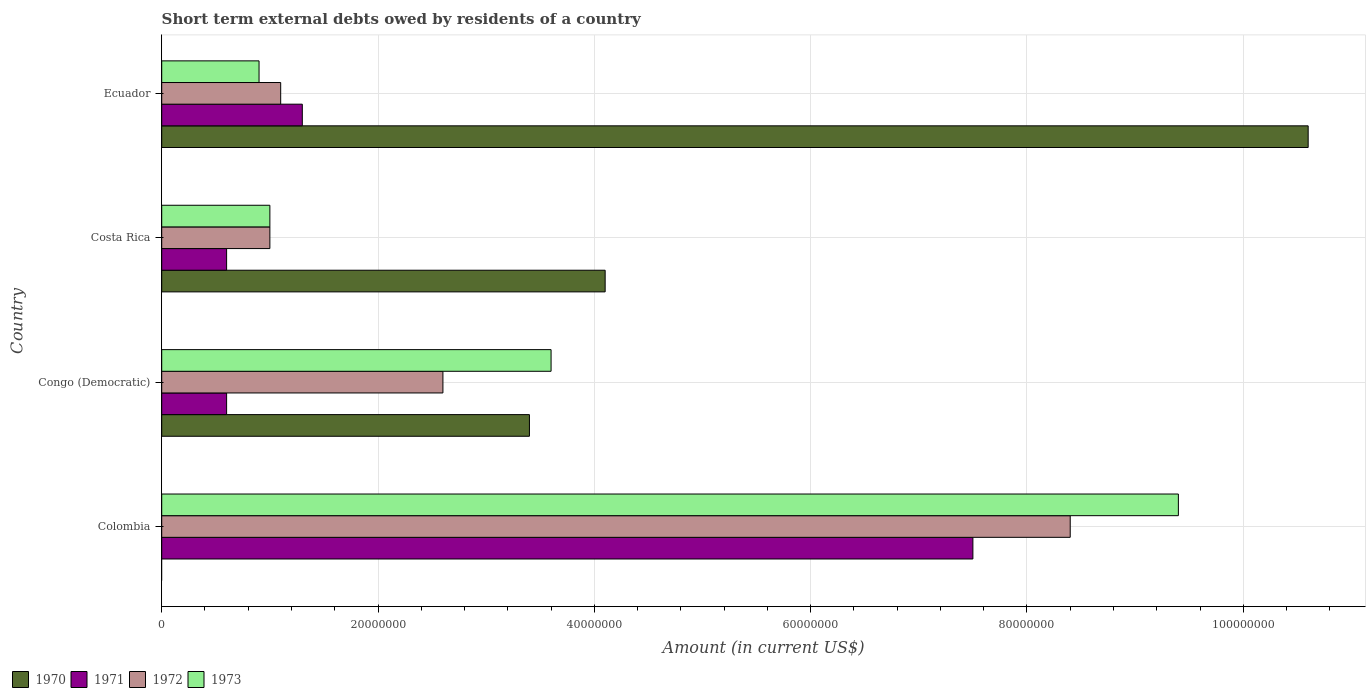How many different coloured bars are there?
Make the answer very short. 4. How many groups of bars are there?
Your answer should be very brief. 4. Are the number of bars per tick equal to the number of legend labels?
Your response must be concise. No. How many bars are there on the 2nd tick from the bottom?
Your response must be concise. 4. In how many cases, is the number of bars for a given country not equal to the number of legend labels?
Your response must be concise. 1. What is the amount of short-term external debts owed by residents in 1971 in Costa Rica?
Your answer should be very brief. 6.00e+06. Across all countries, what is the maximum amount of short-term external debts owed by residents in 1971?
Your response must be concise. 7.50e+07. Across all countries, what is the minimum amount of short-term external debts owed by residents in 1971?
Make the answer very short. 6.00e+06. In which country was the amount of short-term external debts owed by residents in 1970 maximum?
Your answer should be compact. Ecuador. What is the difference between the amount of short-term external debts owed by residents in 1971 in Colombia and that in Costa Rica?
Keep it short and to the point. 6.90e+07. What is the difference between the amount of short-term external debts owed by residents in 1972 in Costa Rica and the amount of short-term external debts owed by residents in 1970 in Ecuador?
Ensure brevity in your answer.  -9.60e+07. What is the average amount of short-term external debts owed by residents in 1971 per country?
Provide a short and direct response. 2.50e+07. What is the difference between the amount of short-term external debts owed by residents in 1972 and amount of short-term external debts owed by residents in 1971 in Costa Rica?
Give a very brief answer. 4.00e+06. In how many countries, is the amount of short-term external debts owed by residents in 1971 greater than 64000000 US$?
Offer a terse response. 1. Is the difference between the amount of short-term external debts owed by residents in 1972 in Colombia and Congo (Democratic) greater than the difference between the amount of short-term external debts owed by residents in 1971 in Colombia and Congo (Democratic)?
Provide a succinct answer. No. What is the difference between the highest and the second highest amount of short-term external debts owed by residents in 1972?
Provide a short and direct response. 5.80e+07. What is the difference between the highest and the lowest amount of short-term external debts owed by residents in 1973?
Your response must be concise. 8.50e+07. In how many countries, is the amount of short-term external debts owed by residents in 1973 greater than the average amount of short-term external debts owed by residents in 1973 taken over all countries?
Your answer should be very brief. 1. Is it the case that in every country, the sum of the amount of short-term external debts owed by residents in 1970 and amount of short-term external debts owed by residents in 1973 is greater than the sum of amount of short-term external debts owed by residents in 1972 and amount of short-term external debts owed by residents in 1971?
Make the answer very short. No. Are all the bars in the graph horizontal?
Keep it short and to the point. Yes. How many countries are there in the graph?
Make the answer very short. 4. Does the graph contain grids?
Keep it short and to the point. Yes. What is the title of the graph?
Your response must be concise. Short term external debts owed by residents of a country. What is the label or title of the X-axis?
Your answer should be compact. Amount (in current US$). What is the Amount (in current US$) in 1971 in Colombia?
Offer a terse response. 7.50e+07. What is the Amount (in current US$) in 1972 in Colombia?
Your answer should be very brief. 8.40e+07. What is the Amount (in current US$) of 1973 in Colombia?
Make the answer very short. 9.40e+07. What is the Amount (in current US$) of 1970 in Congo (Democratic)?
Offer a terse response. 3.40e+07. What is the Amount (in current US$) in 1972 in Congo (Democratic)?
Give a very brief answer. 2.60e+07. What is the Amount (in current US$) of 1973 in Congo (Democratic)?
Provide a succinct answer. 3.60e+07. What is the Amount (in current US$) of 1970 in Costa Rica?
Ensure brevity in your answer.  4.10e+07. What is the Amount (in current US$) in 1971 in Costa Rica?
Give a very brief answer. 6.00e+06. What is the Amount (in current US$) of 1972 in Costa Rica?
Give a very brief answer. 1.00e+07. What is the Amount (in current US$) of 1970 in Ecuador?
Provide a short and direct response. 1.06e+08. What is the Amount (in current US$) in 1971 in Ecuador?
Provide a succinct answer. 1.30e+07. What is the Amount (in current US$) of 1972 in Ecuador?
Offer a terse response. 1.10e+07. What is the Amount (in current US$) in 1973 in Ecuador?
Your answer should be compact. 9.00e+06. Across all countries, what is the maximum Amount (in current US$) of 1970?
Your answer should be compact. 1.06e+08. Across all countries, what is the maximum Amount (in current US$) in 1971?
Give a very brief answer. 7.50e+07. Across all countries, what is the maximum Amount (in current US$) in 1972?
Offer a terse response. 8.40e+07. Across all countries, what is the maximum Amount (in current US$) of 1973?
Offer a terse response. 9.40e+07. Across all countries, what is the minimum Amount (in current US$) in 1972?
Offer a terse response. 1.00e+07. Across all countries, what is the minimum Amount (in current US$) in 1973?
Provide a short and direct response. 9.00e+06. What is the total Amount (in current US$) in 1970 in the graph?
Offer a very short reply. 1.81e+08. What is the total Amount (in current US$) in 1971 in the graph?
Provide a short and direct response. 1.00e+08. What is the total Amount (in current US$) of 1972 in the graph?
Keep it short and to the point. 1.31e+08. What is the total Amount (in current US$) in 1973 in the graph?
Give a very brief answer. 1.49e+08. What is the difference between the Amount (in current US$) in 1971 in Colombia and that in Congo (Democratic)?
Keep it short and to the point. 6.90e+07. What is the difference between the Amount (in current US$) in 1972 in Colombia and that in Congo (Democratic)?
Keep it short and to the point. 5.80e+07. What is the difference between the Amount (in current US$) of 1973 in Colombia and that in Congo (Democratic)?
Give a very brief answer. 5.80e+07. What is the difference between the Amount (in current US$) in 1971 in Colombia and that in Costa Rica?
Provide a short and direct response. 6.90e+07. What is the difference between the Amount (in current US$) in 1972 in Colombia and that in Costa Rica?
Offer a terse response. 7.40e+07. What is the difference between the Amount (in current US$) in 1973 in Colombia and that in Costa Rica?
Give a very brief answer. 8.40e+07. What is the difference between the Amount (in current US$) of 1971 in Colombia and that in Ecuador?
Give a very brief answer. 6.20e+07. What is the difference between the Amount (in current US$) of 1972 in Colombia and that in Ecuador?
Give a very brief answer. 7.30e+07. What is the difference between the Amount (in current US$) in 1973 in Colombia and that in Ecuador?
Offer a terse response. 8.50e+07. What is the difference between the Amount (in current US$) in 1970 in Congo (Democratic) and that in Costa Rica?
Your response must be concise. -7.00e+06. What is the difference between the Amount (in current US$) in 1972 in Congo (Democratic) and that in Costa Rica?
Provide a short and direct response. 1.60e+07. What is the difference between the Amount (in current US$) in 1973 in Congo (Democratic) and that in Costa Rica?
Provide a short and direct response. 2.60e+07. What is the difference between the Amount (in current US$) in 1970 in Congo (Democratic) and that in Ecuador?
Keep it short and to the point. -7.20e+07. What is the difference between the Amount (in current US$) in 1971 in Congo (Democratic) and that in Ecuador?
Offer a terse response. -7.00e+06. What is the difference between the Amount (in current US$) of 1972 in Congo (Democratic) and that in Ecuador?
Provide a short and direct response. 1.50e+07. What is the difference between the Amount (in current US$) in 1973 in Congo (Democratic) and that in Ecuador?
Provide a short and direct response. 2.70e+07. What is the difference between the Amount (in current US$) in 1970 in Costa Rica and that in Ecuador?
Keep it short and to the point. -6.50e+07. What is the difference between the Amount (in current US$) of 1971 in Costa Rica and that in Ecuador?
Keep it short and to the point. -7.00e+06. What is the difference between the Amount (in current US$) in 1971 in Colombia and the Amount (in current US$) in 1972 in Congo (Democratic)?
Keep it short and to the point. 4.90e+07. What is the difference between the Amount (in current US$) of 1971 in Colombia and the Amount (in current US$) of 1973 in Congo (Democratic)?
Your answer should be very brief. 3.90e+07. What is the difference between the Amount (in current US$) of 1972 in Colombia and the Amount (in current US$) of 1973 in Congo (Democratic)?
Offer a very short reply. 4.80e+07. What is the difference between the Amount (in current US$) in 1971 in Colombia and the Amount (in current US$) in 1972 in Costa Rica?
Keep it short and to the point. 6.50e+07. What is the difference between the Amount (in current US$) of 1971 in Colombia and the Amount (in current US$) of 1973 in Costa Rica?
Give a very brief answer. 6.50e+07. What is the difference between the Amount (in current US$) of 1972 in Colombia and the Amount (in current US$) of 1973 in Costa Rica?
Keep it short and to the point. 7.40e+07. What is the difference between the Amount (in current US$) of 1971 in Colombia and the Amount (in current US$) of 1972 in Ecuador?
Offer a very short reply. 6.40e+07. What is the difference between the Amount (in current US$) in 1971 in Colombia and the Amount (in current US$) in 1973 in Ecuador?
Give a very brief answer. 6.60e+07. What is the difference between the Amount (in current US$) of 1972 in Colombia and the Amount (in current US$) of 1973 in Ecuador?
Ensure brevity in your answer.  7.50e+07. What is the difference between the Amount (in current US$) in 1970 in Congo (Democratic) and the Amount (in current US$) in 1971 in Costa Rica?
Ensure brevity in your answer.  2.80e+07. What is the difference between the Amount (in current US$) in 1970 in Congo (Democratic) and the Amount (in current US$) in 1972 in Costa Rica?
Your answer should be compact. 2.40e+07. What is the difference between the Amount (in current US$) of 1970 in Congo (Democratic) and the Amount (in current US$) of 1973 in Costa Rica?
Your response must be concise. 2.40e+07. What is the difference between the Amount (in current US$) of 1972 in Congo (Democratic) and the Amount (in current US$) of 1973 in Costa Rica?
Offer a terse response. 1.60e+07. What is the difference between the Amount (in current US$) of 1970 in Congo (Democratic) and the Amount (in current US$) of 1971 in Ecuador?
Make the answer very short. 2.10e+07. What is the difference between the Amount (in current US$) in 1970 in Congo (Democratic) and the Amount (in current US$) in 1972 in Ecuador?
Provide a succinct answer. 2.30e+07. What is the difference between the Amount (in current US$) in 1970 in Congo (Democratic) and the Amount (in current US$) in 1973 in Ecuador?
Your answer should be very brief. 2.50e+07. What is the difference between the Amount (in current US$) of 1971 in Congo (Democratic) and the Amount (in current US$) of 1972 in Ecuador?
Keep it short and to the point. -5.00e+06. What is the difference between the Amount (in current US$) in 1972 in Congo (Democratic) and the Amount (in current US$) in 1973 in Ecuador?
Ensure brevity in your answer.  1.70e+07. What is the difference between the Amount (in current US$) of 1970 in Costa Rica and the Amount (in current US$) of 1971 in Ecuador?
Your answer should be very brief. 2.80e+07. What is the difference between the Amount (in current US$) in 1970 in Costa Rica and the Amount (in current US$) in 1972 in Ecuador?
Ensure brevity in your answer.  3.00e+07. What is the difference between the Amount (in current US$) of 1970 in Costa Rica and the Amount (in current US$) of 1973 in Ecuador?
Offer a very short reply. 3.20e+07. What is the difference between the Amount (in current US$) of 1971 in Costa Rica and the Amount (in current US$) of 1972 in Ecuador?
Make the answer very short. -5.00e+06. What is the difference between the Amount (in current US$) in 1972 in Costa Rica and the Amount (in current US$) in 1973 in Ecuador?
Your answer should be very brief. 1.00e+06. What is the average Amount (in current US$) of 1970 per country?
Give a very brief answer. 4.52e+07. What is the average Amount (in current US$) in 1971 per country?
Keep it short and to the point. 2.50e+07. What is the average Amount (in current US$) in 1972 per country?
Make the answer very short. 3.28e+07. What is the average Amount (in current US$) of 1973 per country?
Offer a terse response. 3.72e+07. What is the difference between the Amount (in current US$) of 1971 and Amount (in current US$) of 1972 in Colombia?
Provide a short and direct response. -9.00e+06. What is the difference between the Amount (in current US$) in 1971 and Amount (in current US$) in 1973 in Colombia?
Offer a terse response. -1.90e+07. What is the difference between the Amount (in current US$) of 1972 and Amount (in current US$) of 1973 in Colombia?
Keep it short and to the point. -1.00e+07. What is the difference between the Amount (in current US$) of 1970 and Amount (in current US$) of 1971 in Congo (Democratic)?
Offer a very short reply. 2.80e+07. What is the difference between the Amount (in current US$) in 1970 and Amount (in current US$) in 1972 in Congo (Democratic)?
Provide a short and direct response. 8.00e+06. What is the difference between the Amount (in current US$) in 1970 and Amount (in current US$) in 1973 in Congo (Democratic)?
Make the answer very short. -2.00e+06. What is the difference between the Amount (in current US$) in 1971 and Amount (in current US$) in 1972 in Congo (Democratic)?
Provide a succinct answer. -2.00e+07. What is the difference between the Amount (in current US$) in 1971 and Amount (in current US$) in 1973 in Congo (Democratic)?
Ensure brevity in your answer.  -3.00e+07. What is the difference between the Amount (in current US$) in 1972 and Amount (in current US$) in 1973 in Congo (Democratic)?
Ensure brevity in your answer.  -1.00e+07. What is the difference between the Amount (in current US$) of 1970 and Amount (in current US$) of 1971 in Costa Rica?
Provide a short and direct response. 3.50e+07. What is the difference between the Amount (in current US$) in 1970 and Amount (in current US$) in 1972 in Costa Rica?
Offer a terse response. 3.10e+07. What is the difference between the Amount (in current US$) of 1970 and Amount (in current US$) of 1973 in Costa Rica?
Your response must be concise. 3.10e+07. What is the difference between the Amount (in current US$) in 1971 and Amount (in current US$) in 1972 in Costa Rica?
Keep it short and to the point. -4.00e+06. What is the difference between the Amount (in current US$) of 1970 and Amount (in current US$) of 1971 in Ecuador?
Offer a very short reply. 9.30e+07. What is the difference between the Amount (in current US$) in 1970 and Amount (in current US$) in 1972 in Ecuador?
Offer a very short reply. 9.50e+07. What is the difference between the Amount (in current US$) in 1970 and Amount (in current US$) in 1973 in Ecuador?
Provide a succinct answer. 9.70e+07. What is the ratio of the Amount (in current US$) in 1971 in Colombia to that in Congo (Democratic)?
Provide a succinct answer. 12.5. What is the ratio of the Amount (in current US$) in 1972 in Colombia to that in Congo (Democratic)?
Give a very brief answer. 3.23. What is the ratio of the Amount (in current US$) in 1973 in Colombia to that in Congo (Democratic)?
Offer a very short reply. 2.61. What is the ratio of the Amount (in current US$) in 1971 in Colombia to that in Ecuador?
Make the answer very short. 5.77. What is the ratio of the Amount (in current US$) in 1972 in Colombia to that in Ecuador?
Your answer should be very brief. 7.64. What is the ratio of the Amount (in current US$) in 1973 in Colombia to that in Ecuador?
Your answer should be compact. 10.44. What is the ratio of the Amount (in current US$) in 1970 in Congo (Democratic) to that in Costa Rica?
Your answer should be very brief. 0.83. What is the ratio of the Amount (in current US$) of 1970 in Congo (Democratic) to that in Ecuador?
Offer a very short reply. 0.32. What is the ratio of the Amount (in current US$) in 1971 in Congo (Democratic) to that in Ecuador?
Keep it short and to the point. 0.46. What is the ratio of the Amount (in current US$) of 1972 in Congo (Democratic) to that in Ecuador?
Ensure brevity in your answer.  2.36. What is the ratio of the Amount (in current US$) of 1970 in Costa Rica to that in Ecuador?
Provide a succinct answer. 0.39. What is the ratio of the Amount (in current US$) in 1971 in Costa Rica to that in Ecuador?
Your answer should be very brief. 0.46. What is the difference between the highest and the second highest Amount (in current US$) in 1970?
Provide a succinct answer. 6.50e+07. What is the difference between the highest and the second highest Amount (in current US$) of 1971?
Your answer should be very brief. 6.20e+07. What is the difference between the highest and the second highest Amount (in current US$) of 1972?
Your answer should be very brief. 5.80e+07. What is the difference between the highest and the second highest Amount (in current US$) of 1973?
Your answer should be compact. 5.80e+07. What is the difference between the highest and the lowest Amount (in current US$) in 1970?
Make the answer very short. 1.06e+08. What is the difference between the highest and the lowest Amount (in current US$) in 1971?
Your response must be concise. 6.90e+07. What is the difference between the highest and the lowest Amount (in current US$) of 1972?
Your answer should be compact. 7.40e+07. What is the difference between the highest and the lowest Amount (in current US$) of 1973?
Your response must be concise. 8.50e+07. 